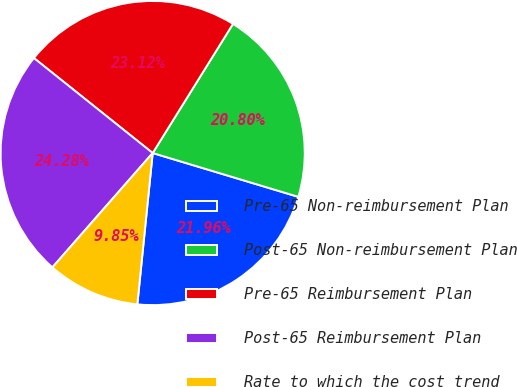Convert chart. <chart><loc_0><loc_0><loc_500><loc_500><pie_chart><fcel>Pre-65 Non-reimbursement Plan<fcel>Post-65 Non-reimbursement Plan<fcel>Pre-65 Reimbursement Plan<fcel>Post-65 Reimbursement Plan<fcel>Rate to which the cost trend<nl><fcel>21.96%<fcel>20.8%<fcel>23.12%<fcel>24.28%<fcel>9.85%<nl></chart> 